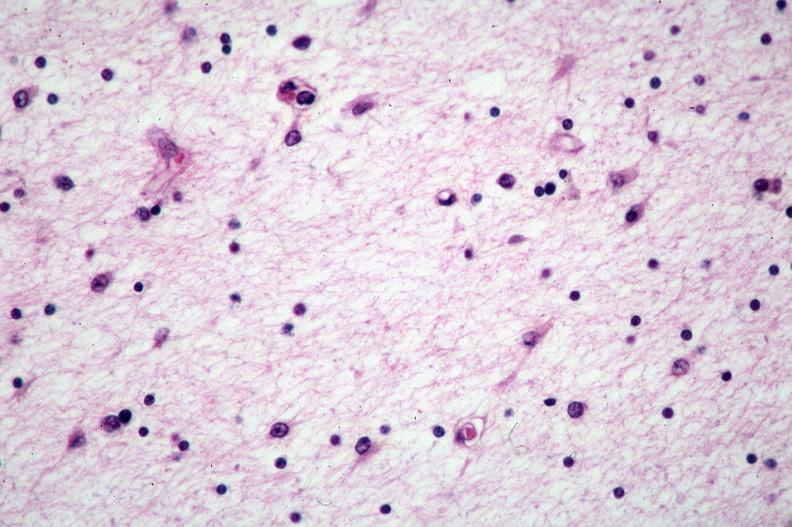what does this image show?
Answer the question using a single word or phrase. Brain 